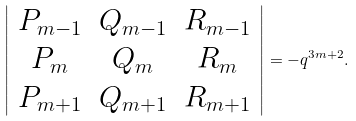<formula> <loc_0><loc_0><loc_500><loc_500>\left | \begin{array} { c c c } P _ { m - 1 } & Q _ { m - 1 } & R _ { m - 1 } \\ P _ { m } & Q _ { m } & R _ { m } \\ P _ { m + 1 } & Q _ { m + 1 } & R _ { m + 1 } \\ \end{array} \right | = - q ^ { 3 m + 2 } .</formula> 